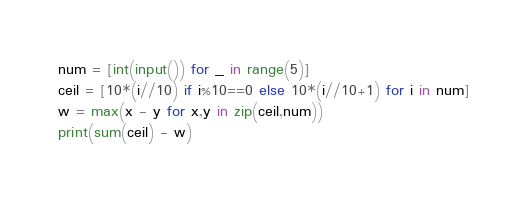Convert code to text. <code><loc_0><loc_0><loc_500><loc_500><_Python_>num = [int(input()) for _ in range(5)]
ceil = [10*(i//10) if i%10==0 else 10*(i//10+1) for i in num]
w = max(x - y for x,y in zip(ceil,num))
print(sum(ceil) - w)
</code> 